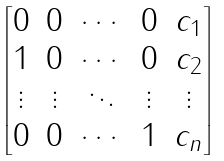<formula> <loc_0><loc_0><loc_500><loc_500>\begin{bmatrix} 0 & 0 & \cdots & 0 & c _ { 1 } \\ 1 & 0 & \cdots & 0 & c _ { 2 } \\ \vdots & \vdots & \ddots & \vdots & \vdots \\ 0 & 0 & \cdots & 1 & c _ { n } \end{bmatrix}</formula> 